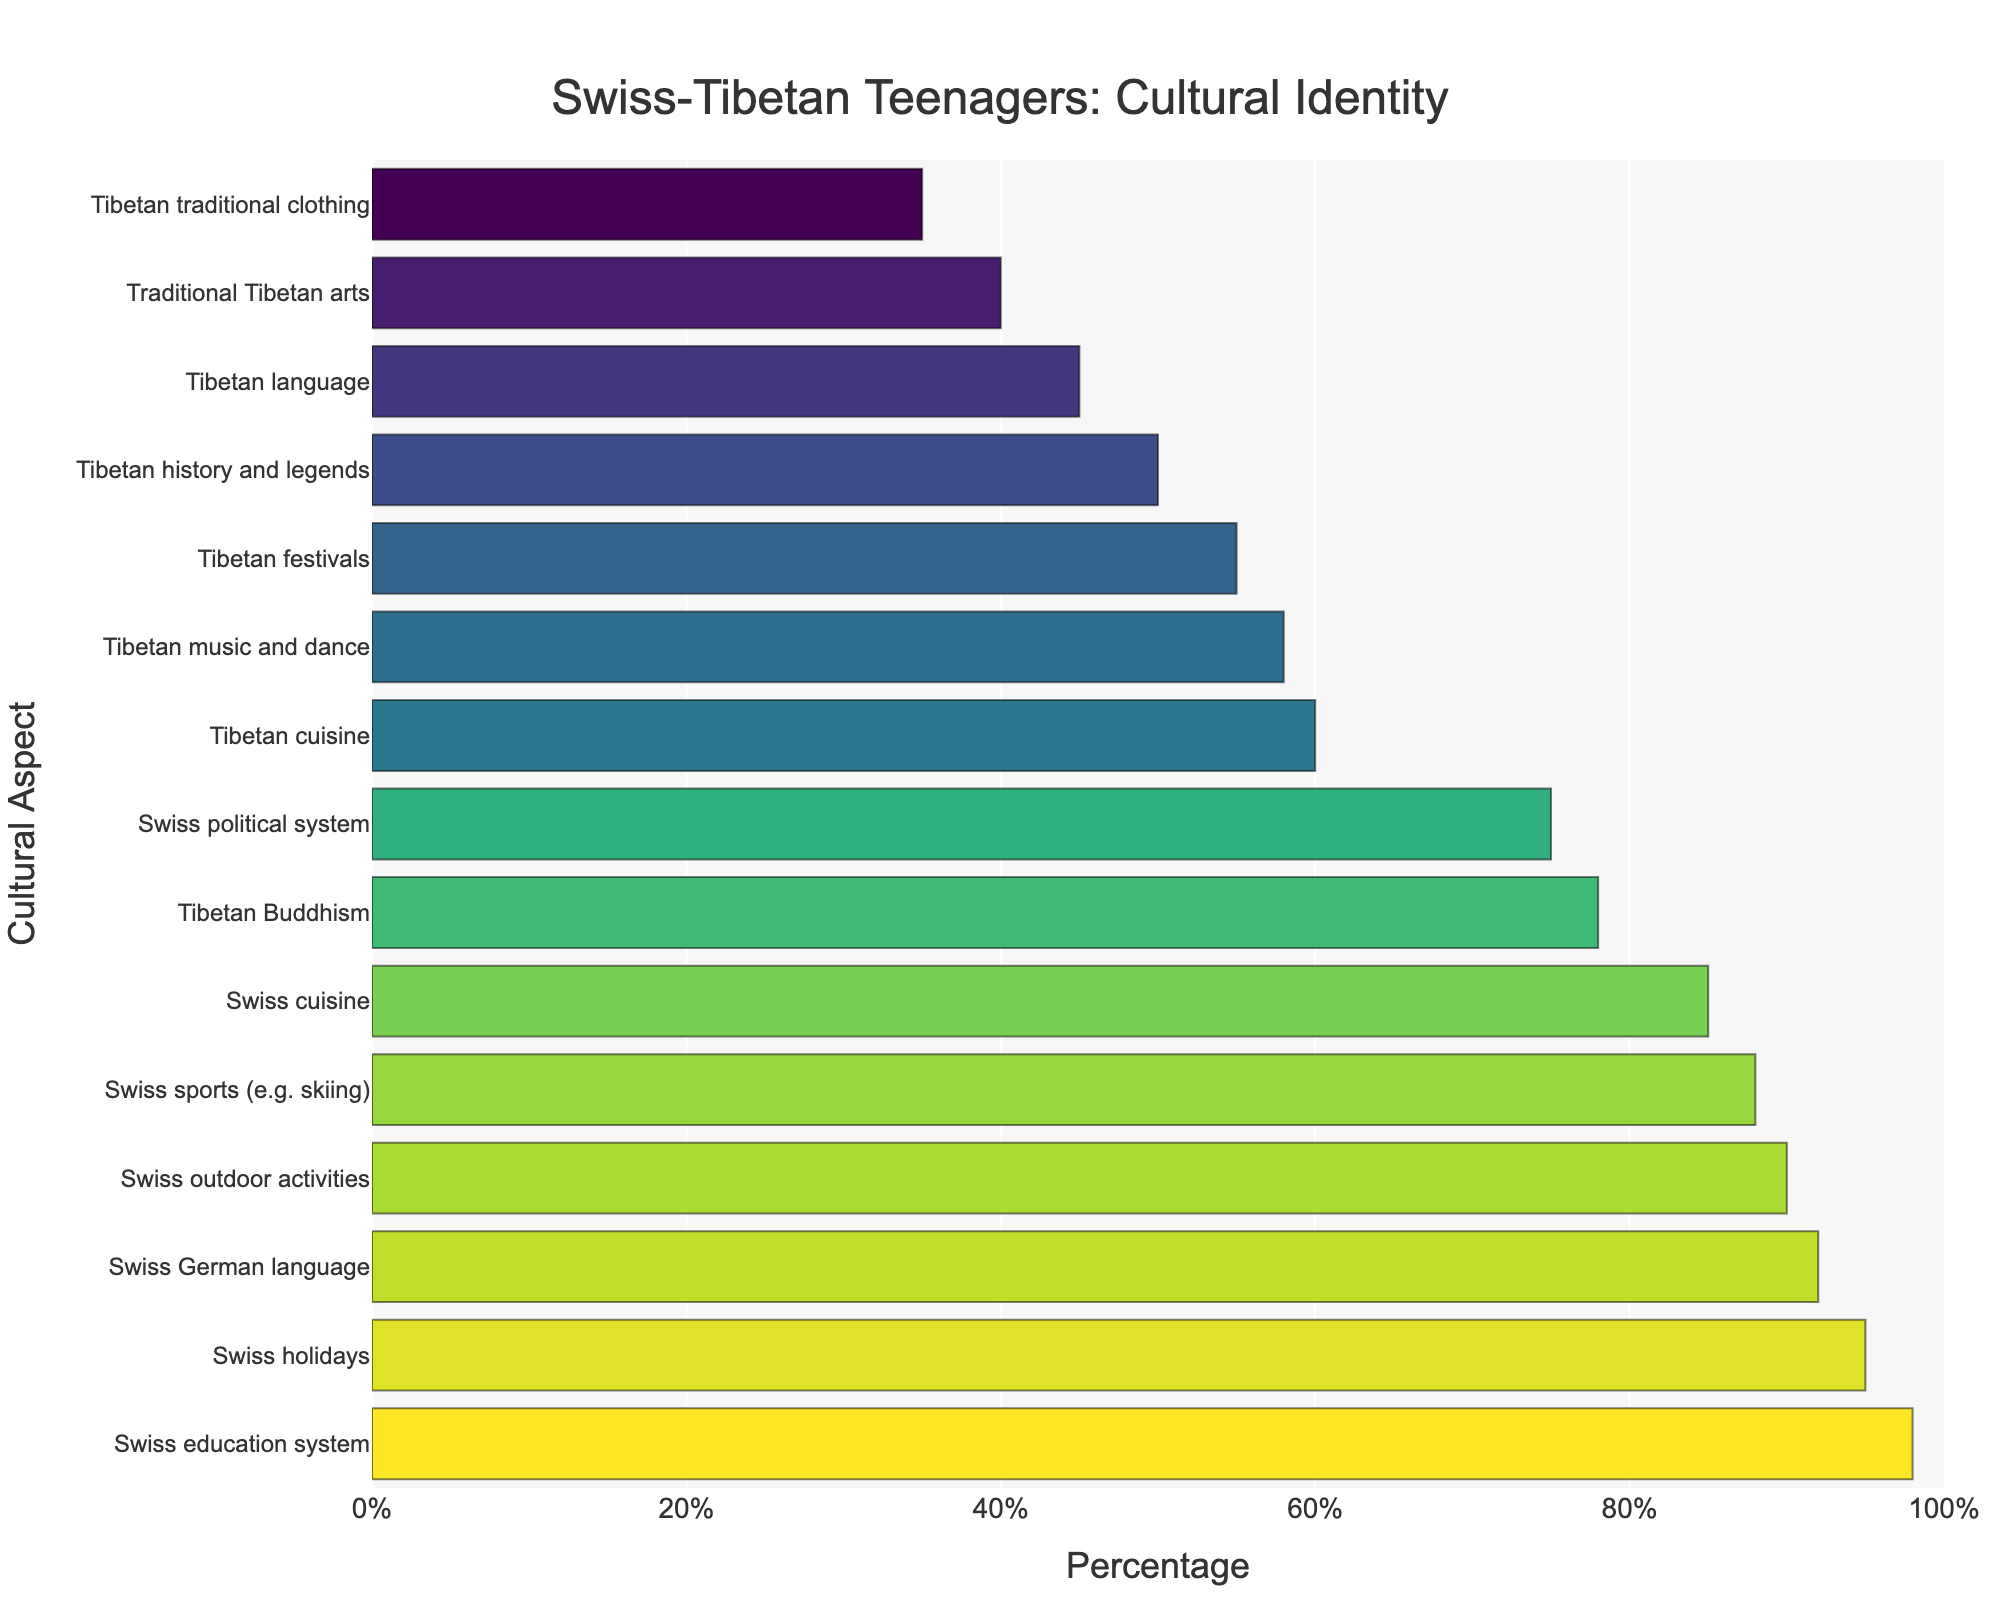Which cultural aspect has the highest percentage of identification among Swiss-Tibetan teenagers? The highest percentage bar is for "Swiss education system" which reaches 98%.
Answer: Swiss education system Which cultural aspect related to Tibetan culture has the lowest percentage of identification? The lowest percentage bar related to Tibetan culture is for "Tibetan traditional clothing" which stands at 35%.
Answer: Tibetan traditional clothing What is the difference in percentage between "Swiss holidays" and "Tibetan festivals"? "Swiss holidays" has a percentage of 95%, while "Tibetan festivals" has 55%. The difference is 95% - 55% = 40%.
Answer: 40% Which has a higher percentage, "Tibetan Buddhism" or "Swiss sports (e.g. skiing)"? "Swiss sports (e.g. skiing)" has a higher percentage of 88% compared to "Tibetan Buddhism" at 78%.
Answer: Swiss sports (e.g. skiing) What is the average percentage of identification for Tibetan cultural aspects? The Tibetan cultural aspects are: "Tibetan Buddhism" (78), "Tibetan language" (45), "Tibetan cuisine" (60), "Tibetan festivals" (55), "Traditional Tibetan arts" (40), "Tibetan history and legends" (50), "Tibetan music and dance" (58), and "Tibetan traditional clothing" (35). The average is (78 + 45 + 60 + 55 + 40 + 50 + 58 + 35) / 8 = 52.625%.
Answer: 52.625% Is the percentage for "Swiss cuisine" more or less than twice the percentage for "Tibetan traditional clothing"? "Swiss cuisine" has a percentage of 85%, and "Tibetan traditional clothing" has 35%. Twice the percentage of "Tibetan traditional clothing" is 35% * 2 = 70%. 85% is more than 70%.
Answer: More What is the range of percentages for Swiss cultural aspects? The lowest percentage for Swiss cultural aspects is 75% (Swiss political system) and the highest is 98% (Swiss education system). The range is 98% - 75% = 23%.
Answer: 23% Which Swiss cultural aspect has the lowest percentage of identification? "Swiss political system" has the lowest percentage at 75%.
Answer: Swiss political system By how many percentage points does "Swiss German language" exceed "Tibetan language"? "Swiss German language" has a percentage of 92%, while "Tibetan language" has 45%. The difference is 92% - 45% = 47%.
Answer: 47% Which category shows more diversity in the range of percentages, Swiss cultural aspects or Tibetan cultural aspects? Tibetan cultural aspects range from 35% to 78%, a span of 43%. Swiss cultural aspects range from 75% to 98%, a span of 23%. Tibetan cultural aspects show more diversity.
Answer: Tibetan cultural aspects 